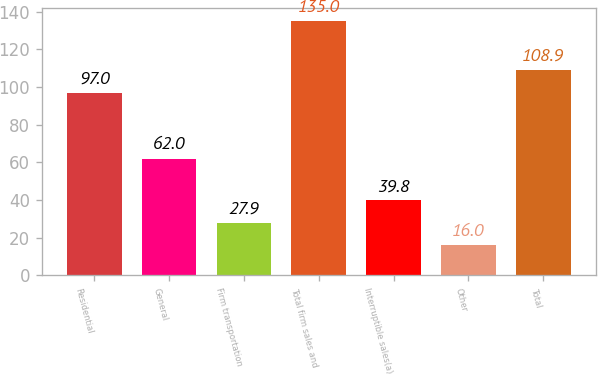Convert chart to OTSL. <chart><loc_0><loc_0><loc_500><loc_500><bar_chart><fcel>Residential<fcel>General<fcel>Firm transportation<fcel>Total firm sales and<fcel>Interruptible sales(a)<fcel>Other<fcel>Total<nl><fcel>97<fcel>62<fcel>27.9<fcel>135<fcel>39.8<fcel>16<fcel>108.9<nl></chart> 